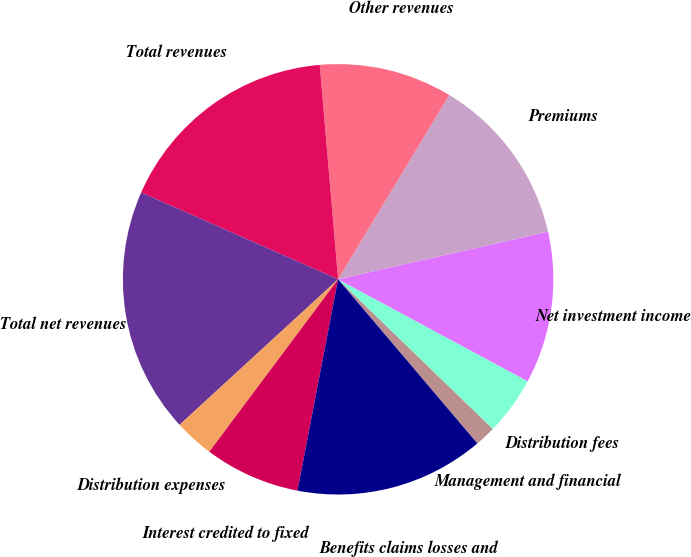Convert chart. <chart><loc_0><loc_0><loc_500><loc_500><pie_chart><fcel>Management and financial<fcel>Distribution fees<fcel>Net investment income<fcel>Premiums<fcel>Other revenues<fcel>Total revenues<fcel>Total net revenues<fcel>Distribution expenses<fcel>Interest credited to fixed<fcel>Benefits claims losses and<nl><fcel>1.57%<fcel>4.38%<fcel>11.41%<fcel>12.81%<fcel>10.0%<fcel>17.03%<fcel>18.43%<fcel>2.97%<fcel>7.19%<fcel>14.22%<nl></chart> 